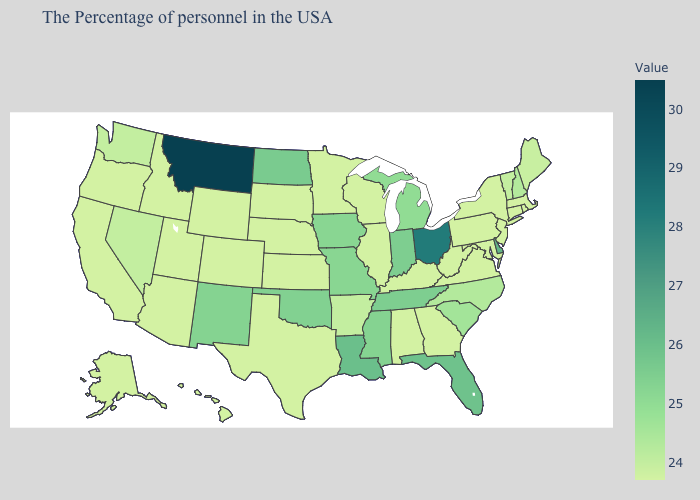Which states have the lowest value in the USA?
Be succinct. Massachusetts, Rhode Island, Connecticut, New York, New Jersey, Maryland, Pennsylvania, Virginia, West Virginia, Georgia, Kentucky, Alabama, Wisconsin, Illinois, Minnesota, Kansas, Nebraska, Texas, South Dakota, Wyoming, Colorado, Utah, Arizona, Idaho, California, Oregon, Alaska, Hawaii. Does the map have missing data?
Be succinct. No. Which states hav the highest value in the MidWest?
Quick response, please. Ohio. 